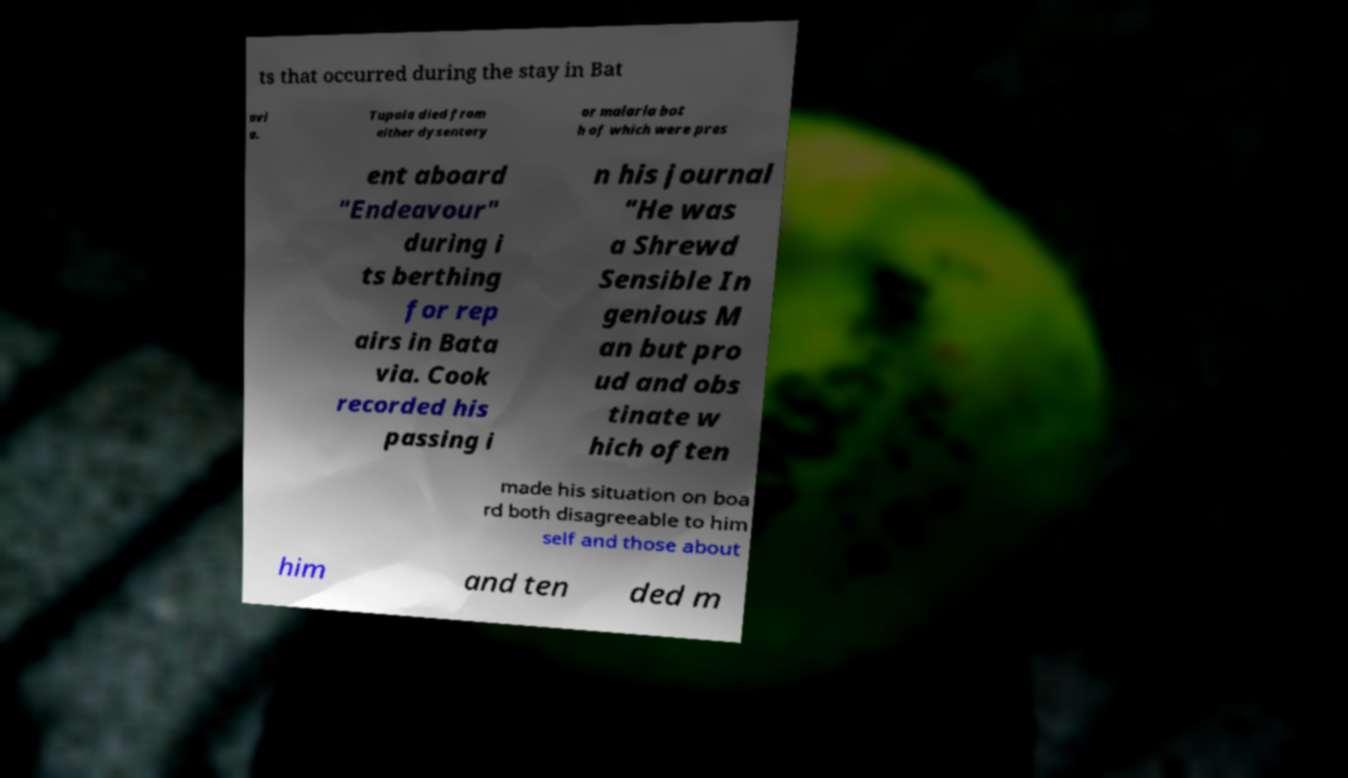What messages or text are displayed in this image? I need them in a readable, typed format. ts that occurred during the stay in Bat avi a. Tupaia died from either dysentery or malaria bot h of which were pres ent aboard "Endeavour" during i ts berthing for rep airs in Bata via. Cook recorded his passing i n his journal "He was a Shrewd Sensible In genious M an but pro ud and obs tinate w hich often made his situation on boa rd both disagreeable to him self and those about him and ten ded m 